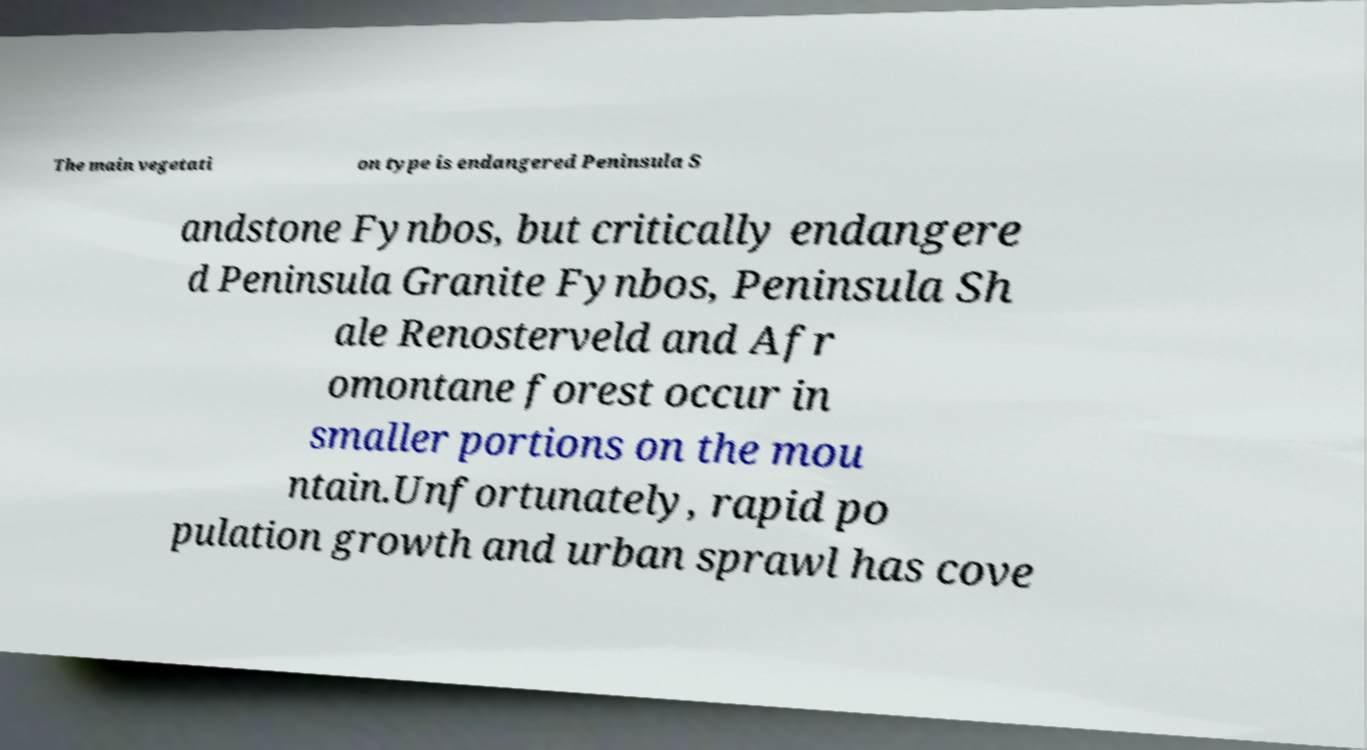What messages or text are displayed in this image? I need them in a readable, typed format. The main vegetati on type is endangered Peninsula S andstone Fynbos, but critically endangere d Peninsula Granite Fynbos, Peninsula Sh ale Renosterveld and Afr omontane forest occur in smaller portions on the mou ntain.Unfortunately, rapid po pulation growth and urban sprawl has cove 